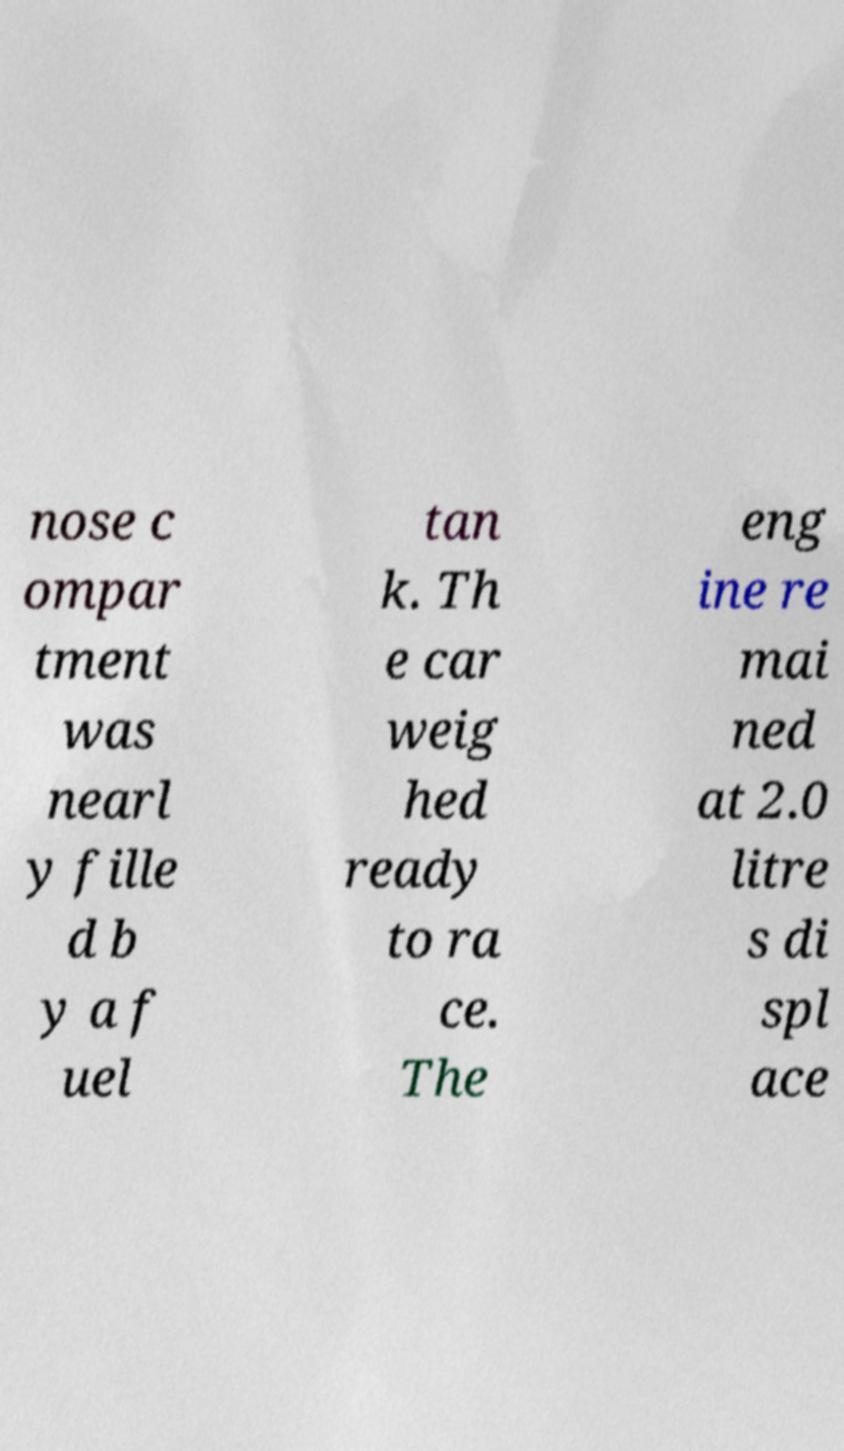Could you assist in decoding the text presented in this image and type it out clearly? nose c ompar tment was nearl y fille d b y a f uel tan k. Th e car weig hed ready to ra ce. The eng ine re mai ned at 2.0 litre s di spl ace 